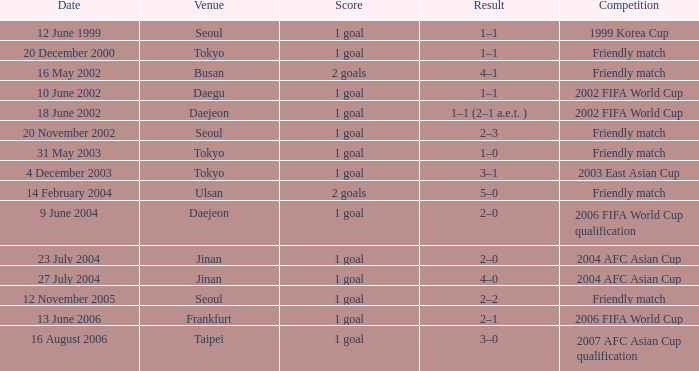What is the venue for the event on 12 November 2005? Seoul. 